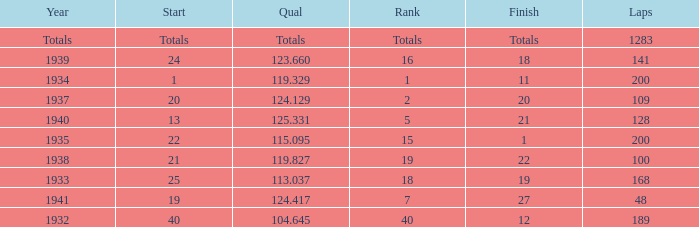What was the rank with the qual of 115.095? 15.0. 